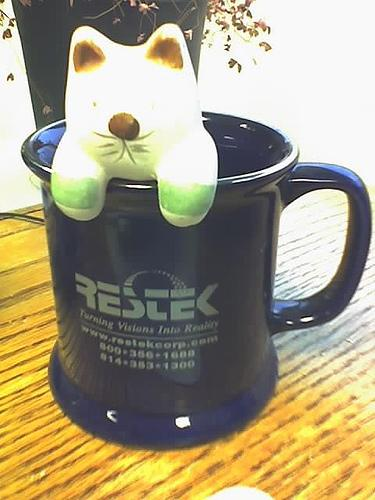Where is Restek's headquarters?

Choices:
A) california
B) florida
C) texas
D) utah california 